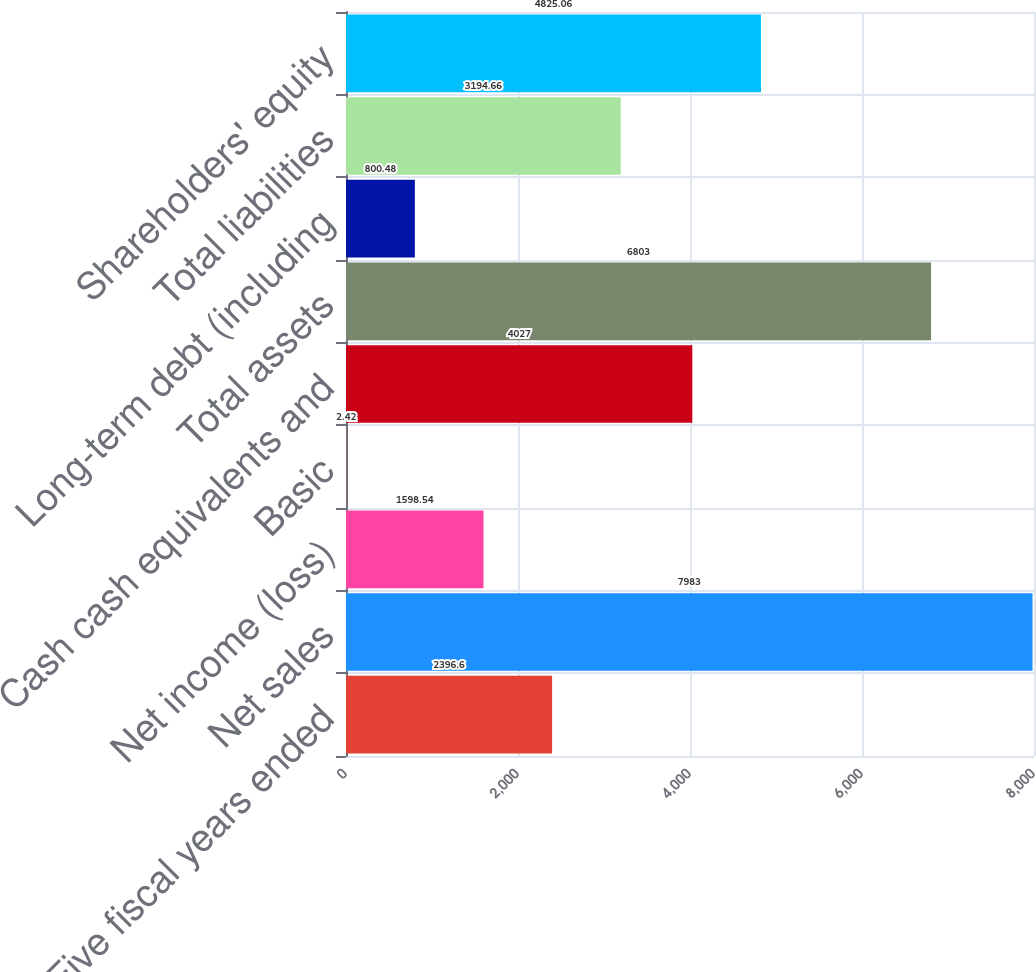Convert chart. <chart><loc_0><loc_0><loc_500><loc_500><bar_chart><fcel>Five fiscal years ended<fcel>Net sales<fcel>Net income (loss)<fcel>Basic<fcel>Cash cash equivalents and<fcel>Total assets<fcel>Long-term debt (including<fcel>Total liabilities<fcel>Shareholders' equity<nl><fcel>2396.6<fcel>7983<fcel>1598.54<fcel>2.42<fcel>4027<fcel>6803<fcel>800.48<fcel>3194.66<fcel>4825.06<nl></chart> 